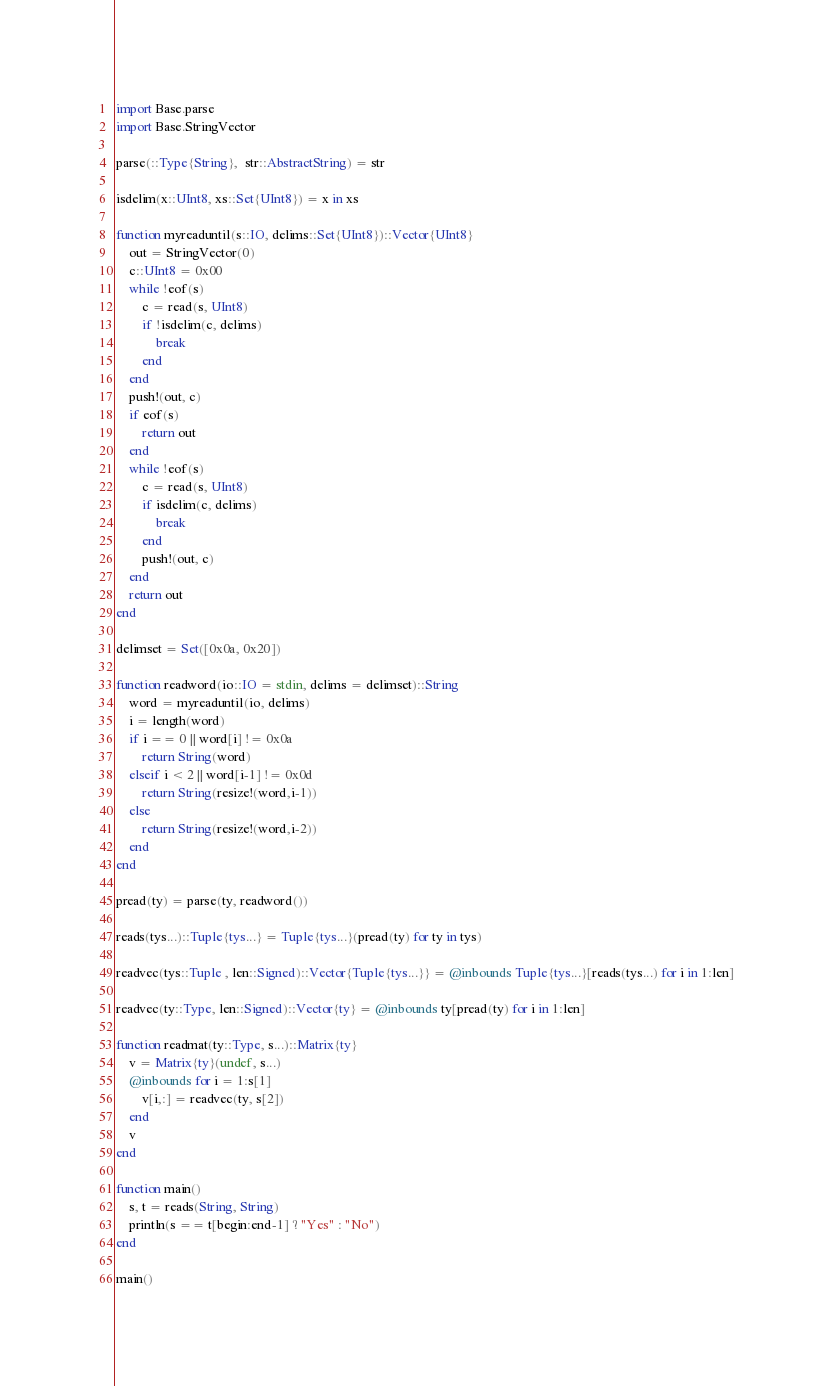Convert code to text. <code><loc_0><loc_0><loc_500><loc_500><_Julia_>import Base.parse
import Base.StringVector

parse(::Type{String},  str::AbstractString) = str

isdelim(x::UInt8, xs::Set{UInt8}) = x in xs

function myreaduntil(s::IO, delims::Set{UInt8})::Vector{UInt8}
    out = StringVector(0)
    c::UInt8 = 0x00
    while !eof(s)
        c = read(s, UInt8)
        if !isdelim(c, delims)
            break
        end
    end
    push!(out, c)
    if eof(s)
        return out
    end
    while !eof(s)
        c = read(s, UInt8)
        if isdelim(c, delims)
            break
        end
        push!(out, c)
    end
    return out
end

delimset = Set([0x0a, 0x20])

function readword(io::IO = stdin, delims = delimset)::String
    word = myreaduntil(io, delims)
    i = length(word)
    if i == 0 || word[i] != 0x0a
        return String(word)
    elseif i < 2 || word[i-1] != 0x0d
        return String(resize!(word,i-1))
    else
        return String(resize!(word,i-2))
    end
end

pread(ty) = parse(ty, readword())

reads(tys...)::Tuple{tys...} = Tuple{tys...}(pread(ty) for ty in tys)

readvec(tys::Tuple , len::Signed)::Vector{Tuple{tys...}} = @inbounds Tuple{tys...}[reads(tys...) for i in 1:len]

readvec(ty::Type, len::Signed)::Vector{ty} = @inbounds ty[pread(ty) for i in 1:len]

function readmat(ty::Type, s...)::Matrix{ty}
    v = Matrix{ty}(undef, s...)
    @inbounds for i = 1:s[1]
        v[i,:] = readvec(ty, s[2])
    end
    v
end

function main()
    s, t = reads(String, String)
    println(s == t[begin:end-1] ? "Yes" : "No")
end

main()
</code> 